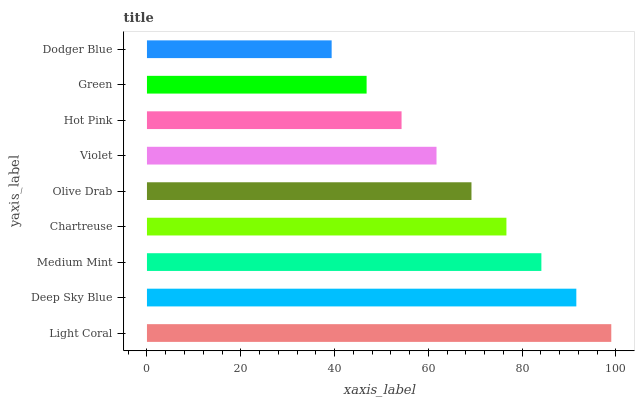Is Dodger Blue the minimum?
Answer yes or no. Yes. Is Light Coral the maximum?
Answer yes or no. Yes. Is Deep Sky Blue the minimum?
Answer yes or no. No. Is Deep Sky Blue the maximum?
Answer yes or no. No. Is Light Coral greater than Deep Sky Blue?
Answer yes or no. Yes. Is Deep Sky Blue less than Light Coral?
Answer yes or no. Yes. Is Deep Sky Blue greater than Light Coral?
Answer yes or no. No. Is Light Coral less than Deep Sky Blue?
Answer yes or no. No. Is Olive Drab the high median?
Answer yes or no. Yes. Is Olive Drab the low median?
Answer yes or no. Yes. Is Light Coral the high median?
Answer yes or no. No. Is Medium Mint the low median?
Answer yes or no. No. 